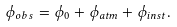Convert formula to latex. <formula><loc_0><loc_0><loc_500><loc_500>\phi _ { o b s } = \phi _ { 0 } + \phi _ { a t m } + \phi _ { i n s t } .</formula> 